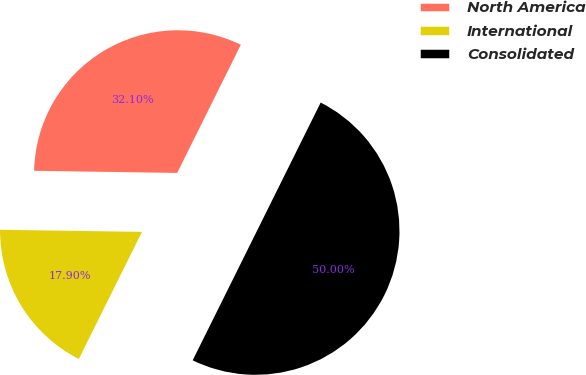Convert chart to OTSL. <chart><loc_0><loc_0><loc_500><loc_500><pie_chart><fcel>North America<fcel>International<fcel>Consolidated<nl><fcel>32.1%<fcel>17.9%<fcel>50.0%<nl></chart> 